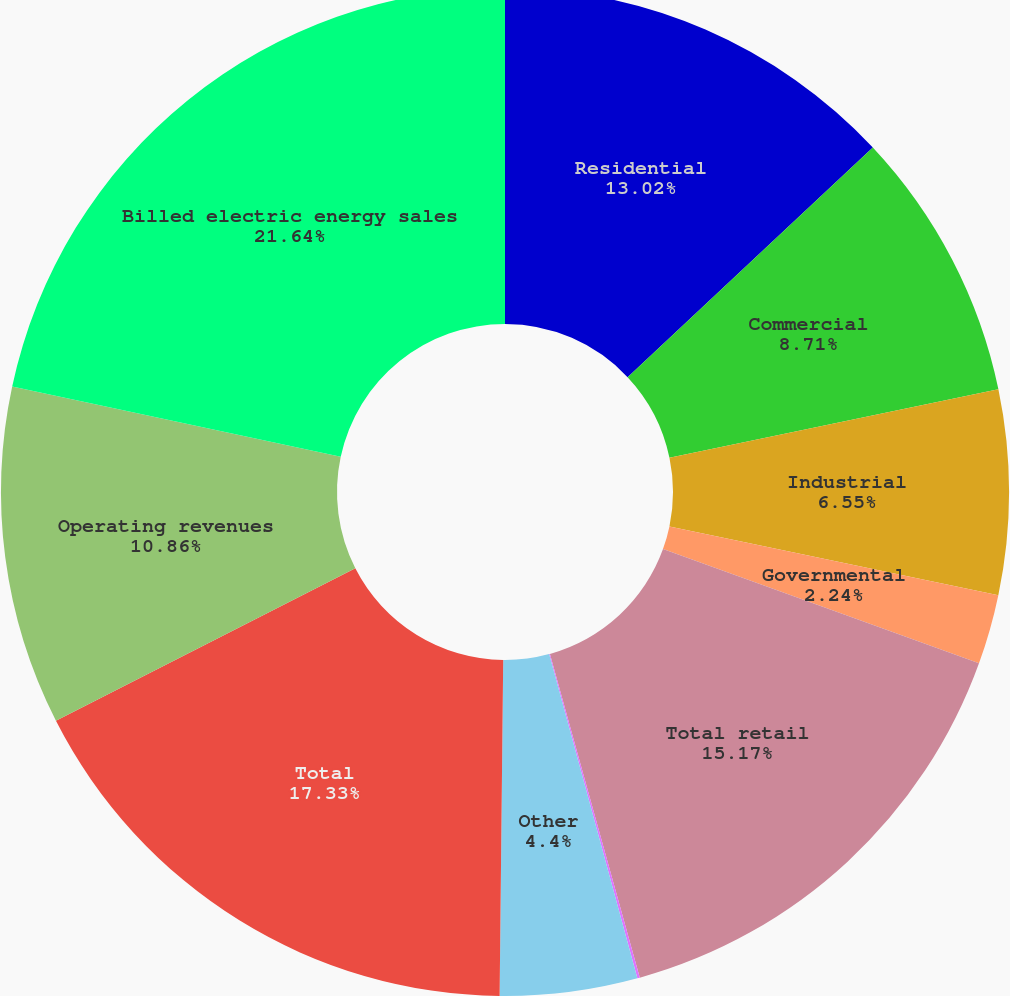Convert chart. <chart><loc_0><loc_0><loc_500><loc_500><pie_chart><fcel>Residential<fcel>Commercial<fcel>Industrial<fcel>Governmental<fcel>Total retail<fcel>Sales for resale<fcel>Other<fcel>Total<fcel>Operating revenues<fcel>Billed electric energy sales<nl><fcel>13.02%<fcel>8.71%<fcel>6.55%<fcel>2.24%<fcel>15.17%<fcel>0.08%<fcel>4.4%<fcel>17.33%<fcel>10.86%<fcel>21.64%<nl></chart> 